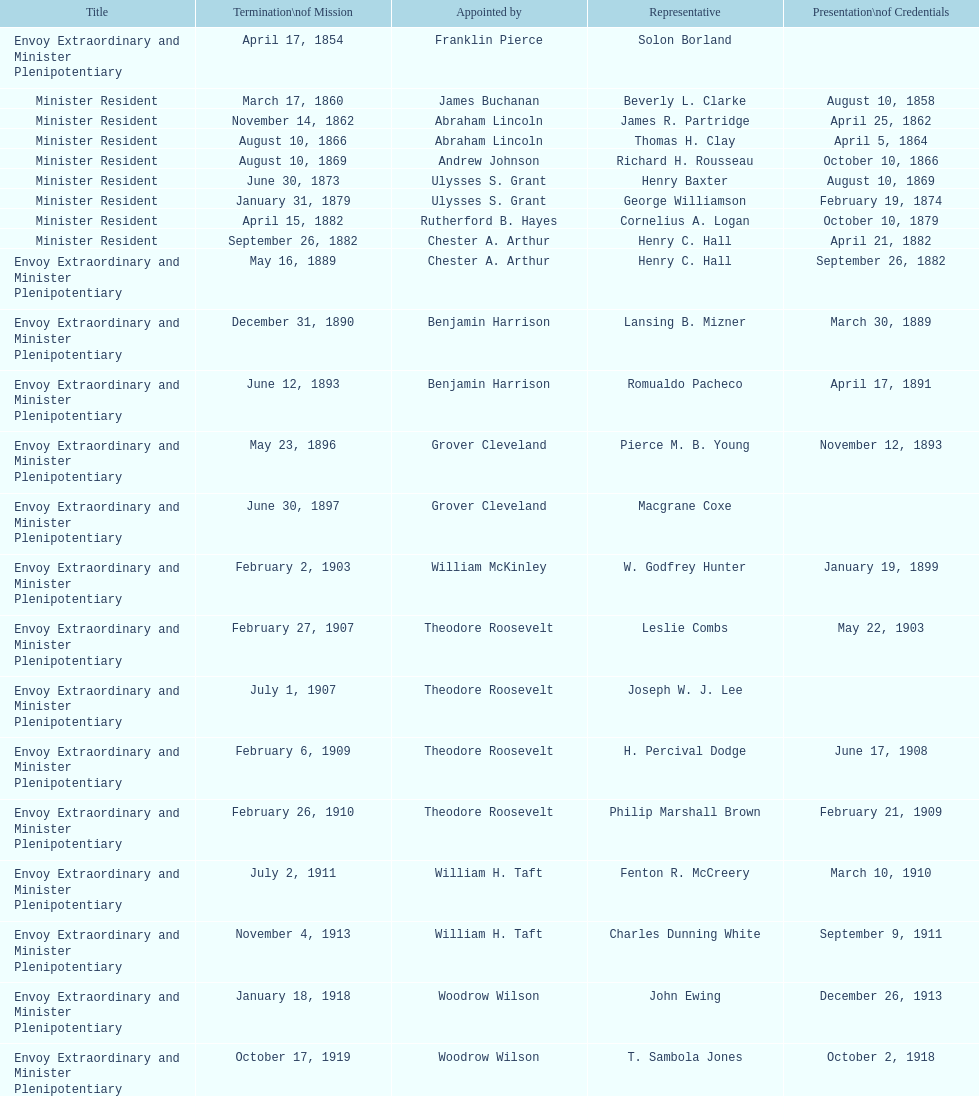Which ambassador to honduras served the longest term? Henry C. Hall. 